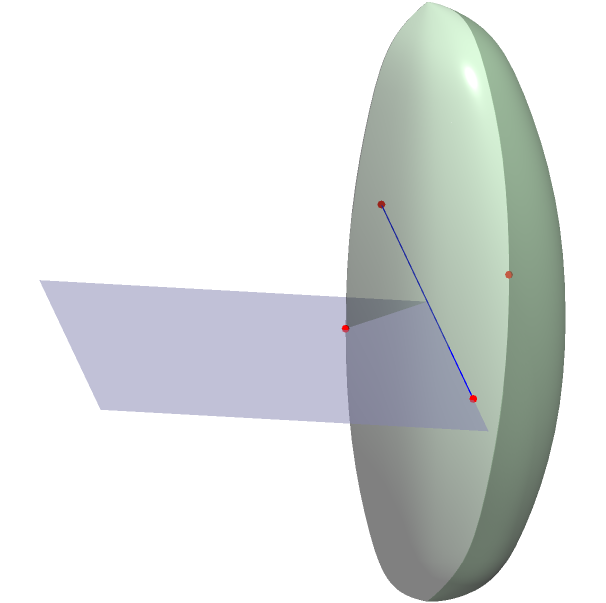As a parent concerned about the quality of education in Chicago Public Schools, you're reviewing your child's geometry homework. You come across a problem comparing the shortest path between two points on different surfaces. In the figure above, compare the shortest path between points A and B on the flat plane (blue) with the shortest path between points C and D on the curved surface (green). Which path is shorter and why? Let's approach this step-by-step:

1) On the flat plane:
   - The shortest path between two points is always a straight line.
   - The distance between A and B can be calculated using the Pythagorean theorem:
     $$d_{AB} = \sqrt{(x_B - x_A)^2 + (y_B - y_A)^2}$$
   - Here, $d_{AB} = \sqrt{(-6-6)^2 + (-6-6)^2} = \sqrt{144 + 144} = \sqrt{288} = 12\sqrt{2}$

2) On the curved surface (sphere):
   - The shortest path between two points on a sphere is along a great circle, which is the intersection of the sphere with a plane passing through the center of the sphere and both points.
   - The distance along this path is an arc length, calculated using the formula:
     $$d_{CD} = R\theta$$
     where $R$ is the radius of the sphere and $\theta$ is the central angle in radians.
   - In this case, $R = 4$ and $\theta = \pi$ (180 degrees or half the circumference).
   - So, $d_{CD} = 4\pi$

3) Comparing the two distances:
   - $d_{AB} = 12\sqrt{2} \approx 16.97$
   - $d_{CD} = 4\pi \approx 12.57$

4) The path on the curved surface (sphere) is shorter, despite appearing longer in the 2D projection.

This demonstrates a key principle of non-Euclidean geometry: the shortest path between two points is not always a straight line, but depends on the nature of the surface.
Answer: The path on the curved surface (sphere) is shorter: $4\pi < 12\sqrt{2}$. 